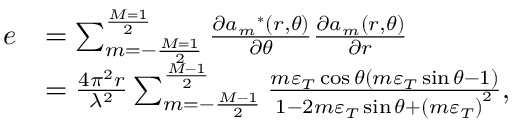Convert formula to latex. <formula><loc_0><loc_0><loc_500><loc_500>\begin{array} { r l } { e } & { = \sum _ { m = - \frac { M = 1 } { 2 } } ^ { \frac { M = 1 } { 2 } } { \frac { { \partial { a _ { m } } ^ { * } ( r , \theta ) } } { \partial \theta } \frac { { \partial { a _ { m } } ( r , \theta ) } } { \partial r } } } \\ & { = \frac { { 4 { \pi ^ { 2 } } r } } { { { \lambda ^ { 2 } } } } \sum _ { m = - \frac { M - 1 } { 2 } } ^ { \frac { M - 1 } { 2 } } { \frac { { m { \varepsilon _ { T } } \cos \theta ( m { \varepsilon _ { T } } \sin \theta - 1 ) } } { { 1 - 2 m { \varepsilon _ { T } } \sin \theta + { { ( m { \varepsilon _ { T } } ) } ^ { 2 } } } } } , } \end{array}</formula> 